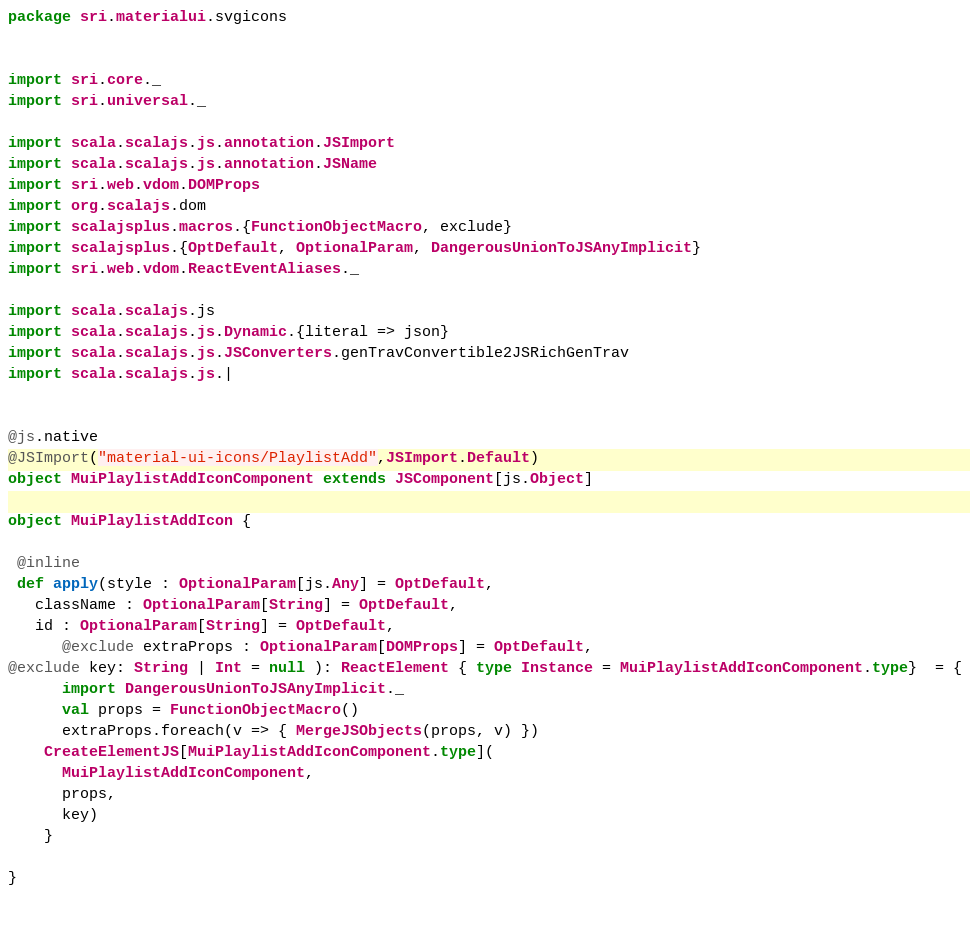<code> <loc_0><loc_0><loc_500><loc_500><_Scala_>package sri.materialui.svgicons


import sri.core._
import sri.universal._

import scala.scalajs.js.annotation.JSImport
import scala.scalajs.js.annotation.JSName
import sri.web.vdom.DOMProps
import org.scalajs.dom
import scalajsplus.macros.{FunctionObjectMacro, exclude}
import scalajsplus.{OptDefault, OptionalParam, DangerousUnionToJSAnyImplicit}
import sri.web.vdom.ReactEventAliases._

import scala.scalajs.js
import scala.scalajs.js.Dynamic.{literal => json}
import scala.scalajs.js.JSConverters.genTravConvertible2JSRichGenTrav
import scala.scalajs.js.|
     

@js.native
@JSImport("material-ui-icons/PlaylistAdd",JSImport.Default)
object MuiPlaylistAddIconComponent extends JSComponent[js.Object]

object MuiPlaylistAddIcon {

 @inline
 def apply(style : OptionalParam[js.Any] = OptDefault,
   className : OptionalParam[String] = OptDefault,
   id : OptionalParam[String] = OptDefault,
      @exclude extraProps : OptionalParam[DOMProps] = OptDefault,
@exclude key: String | Int = null ): ReactElement { type Instance = MuiPlaylistAddIconComponent.type}  = {
      import DangerousUnionToJSAnyImplicit._
      val props = FunctionObjectMacro()
      extraProps.foreach(v => { MergeJSObjects(props, v) })
    CreateElementJS[MuiPlaylistAddIconComponent.type](
      MuiPlaylistAddIconComponent,
      props,
      key)
    }

}

        
</code> 